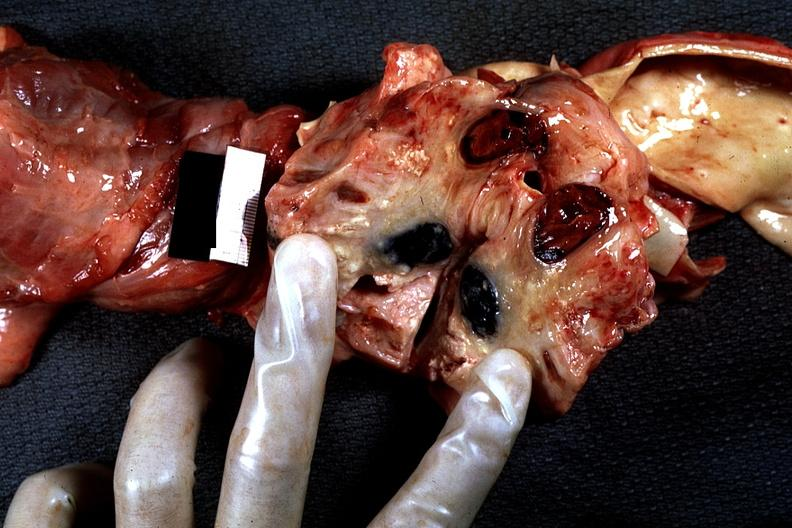what is present?
Answer the question using a single word or phrase. Thorax 